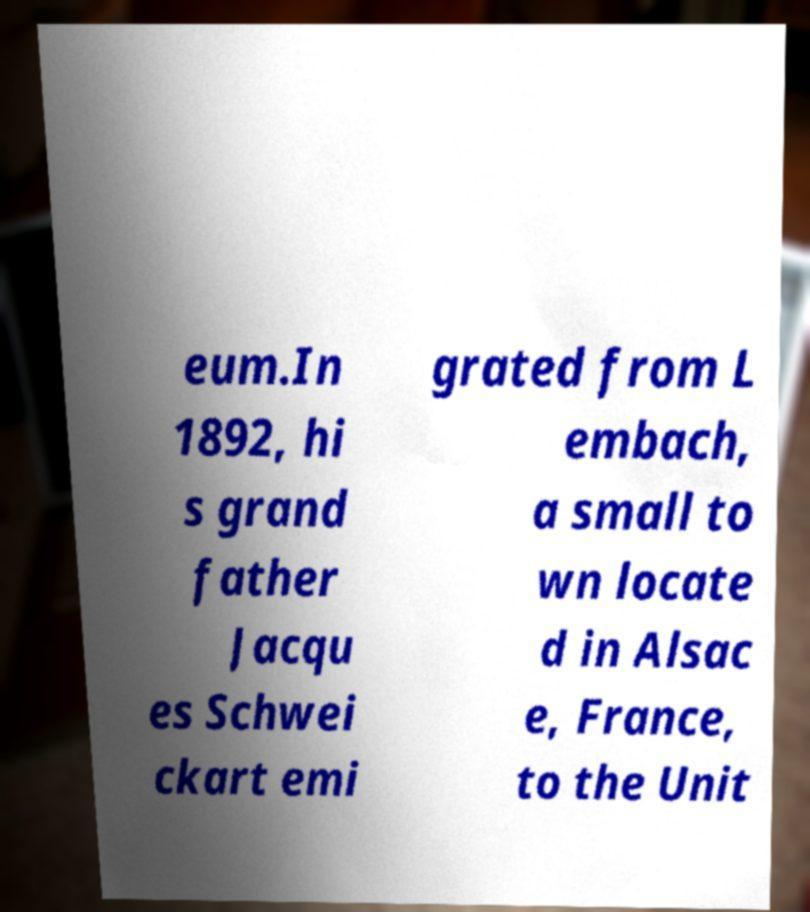Can you accurately transcribe the text from the provided image for me? eum.In 1892, hi s grand father Jacqu es Schwei ckart emi grated from L embach, a small to wn locate d in Alsac e, France, to the Unit 